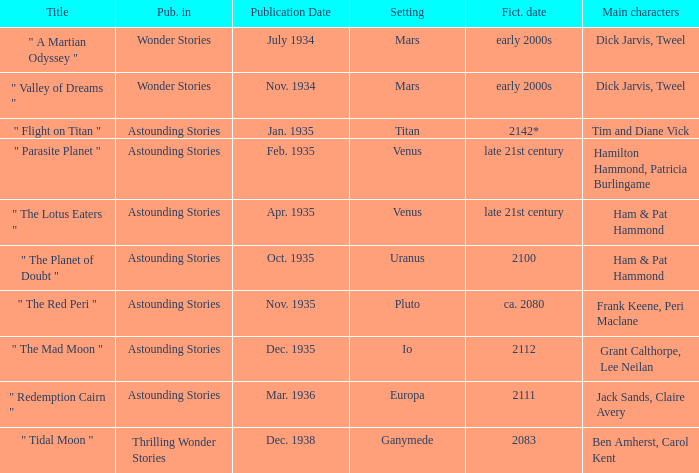Name the publication date when the fictional date is 2112 Dec. 1935. 